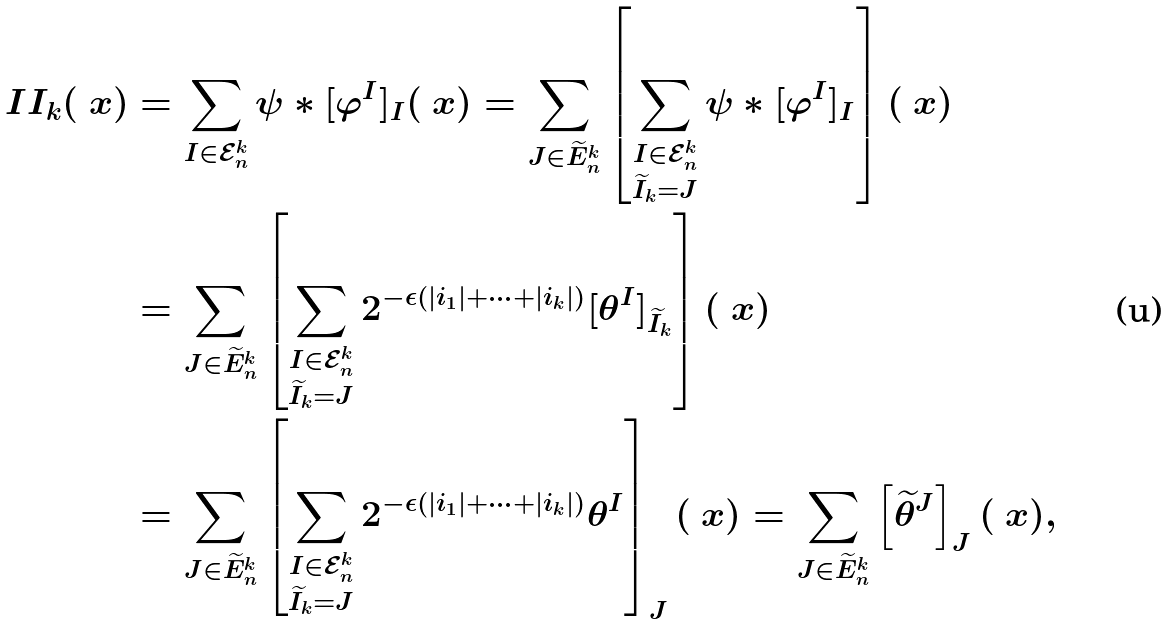<formula> <loc_0><loc_0><loc_500><loc_500>I I _ { k } ( \ x ) & = \sum _ { I \in \mathcal { E } _ { n } ^ { k } } \psi * [ \varphi ^ { I } ] _ { I } ( \ x ) = \sum _ { J \in \widetilde { E } _ { n } ^ { k } } \left [ \sum _ { \substack { I \in \mathcal { E } _ { n } ^ { k } \\ \widetilde { I } _ { k } = J } } \psi * [ \varphi ^ { I } ] _ { I } \right ] ( \ x ) \\ & = \sum _ { J \in \widetilde { E } _ { n } ^ { k } } \left [ \sum _ { \substack { I \in \mathcal { E } _ { n } ^ { k } \\ \widetilde { I } _ { k } = J } } 2 ^ { - \epsilon ( | i _ { 1 } | + \cdots + | i _ { k } | ) } [ \theta ^ { I } ] _ { \widetilde { I } _ { k } } \right ] ( \ x ) \\ & = \sum _ { J \in \widetilde { E } _ { n } ^ { k } } \left [ \sum _ { \substack { I \in \mathcal { E } _ { n } ^ { k } \\ \widetilde { I } _ { k } = J } } 2 ^ { - \epsilon ( | i _ { 1 } | + \cdots + | i _ { k } | ) } \theta ^ { I } \right ] _ { J } ( \ x ) = \sum _ { J \in \widetilde { E } _ { n } ^ { k } } \left [ \widetilde { \theta } ^ { J } \right ] _ { J } ( \ x ) ,</formula> 